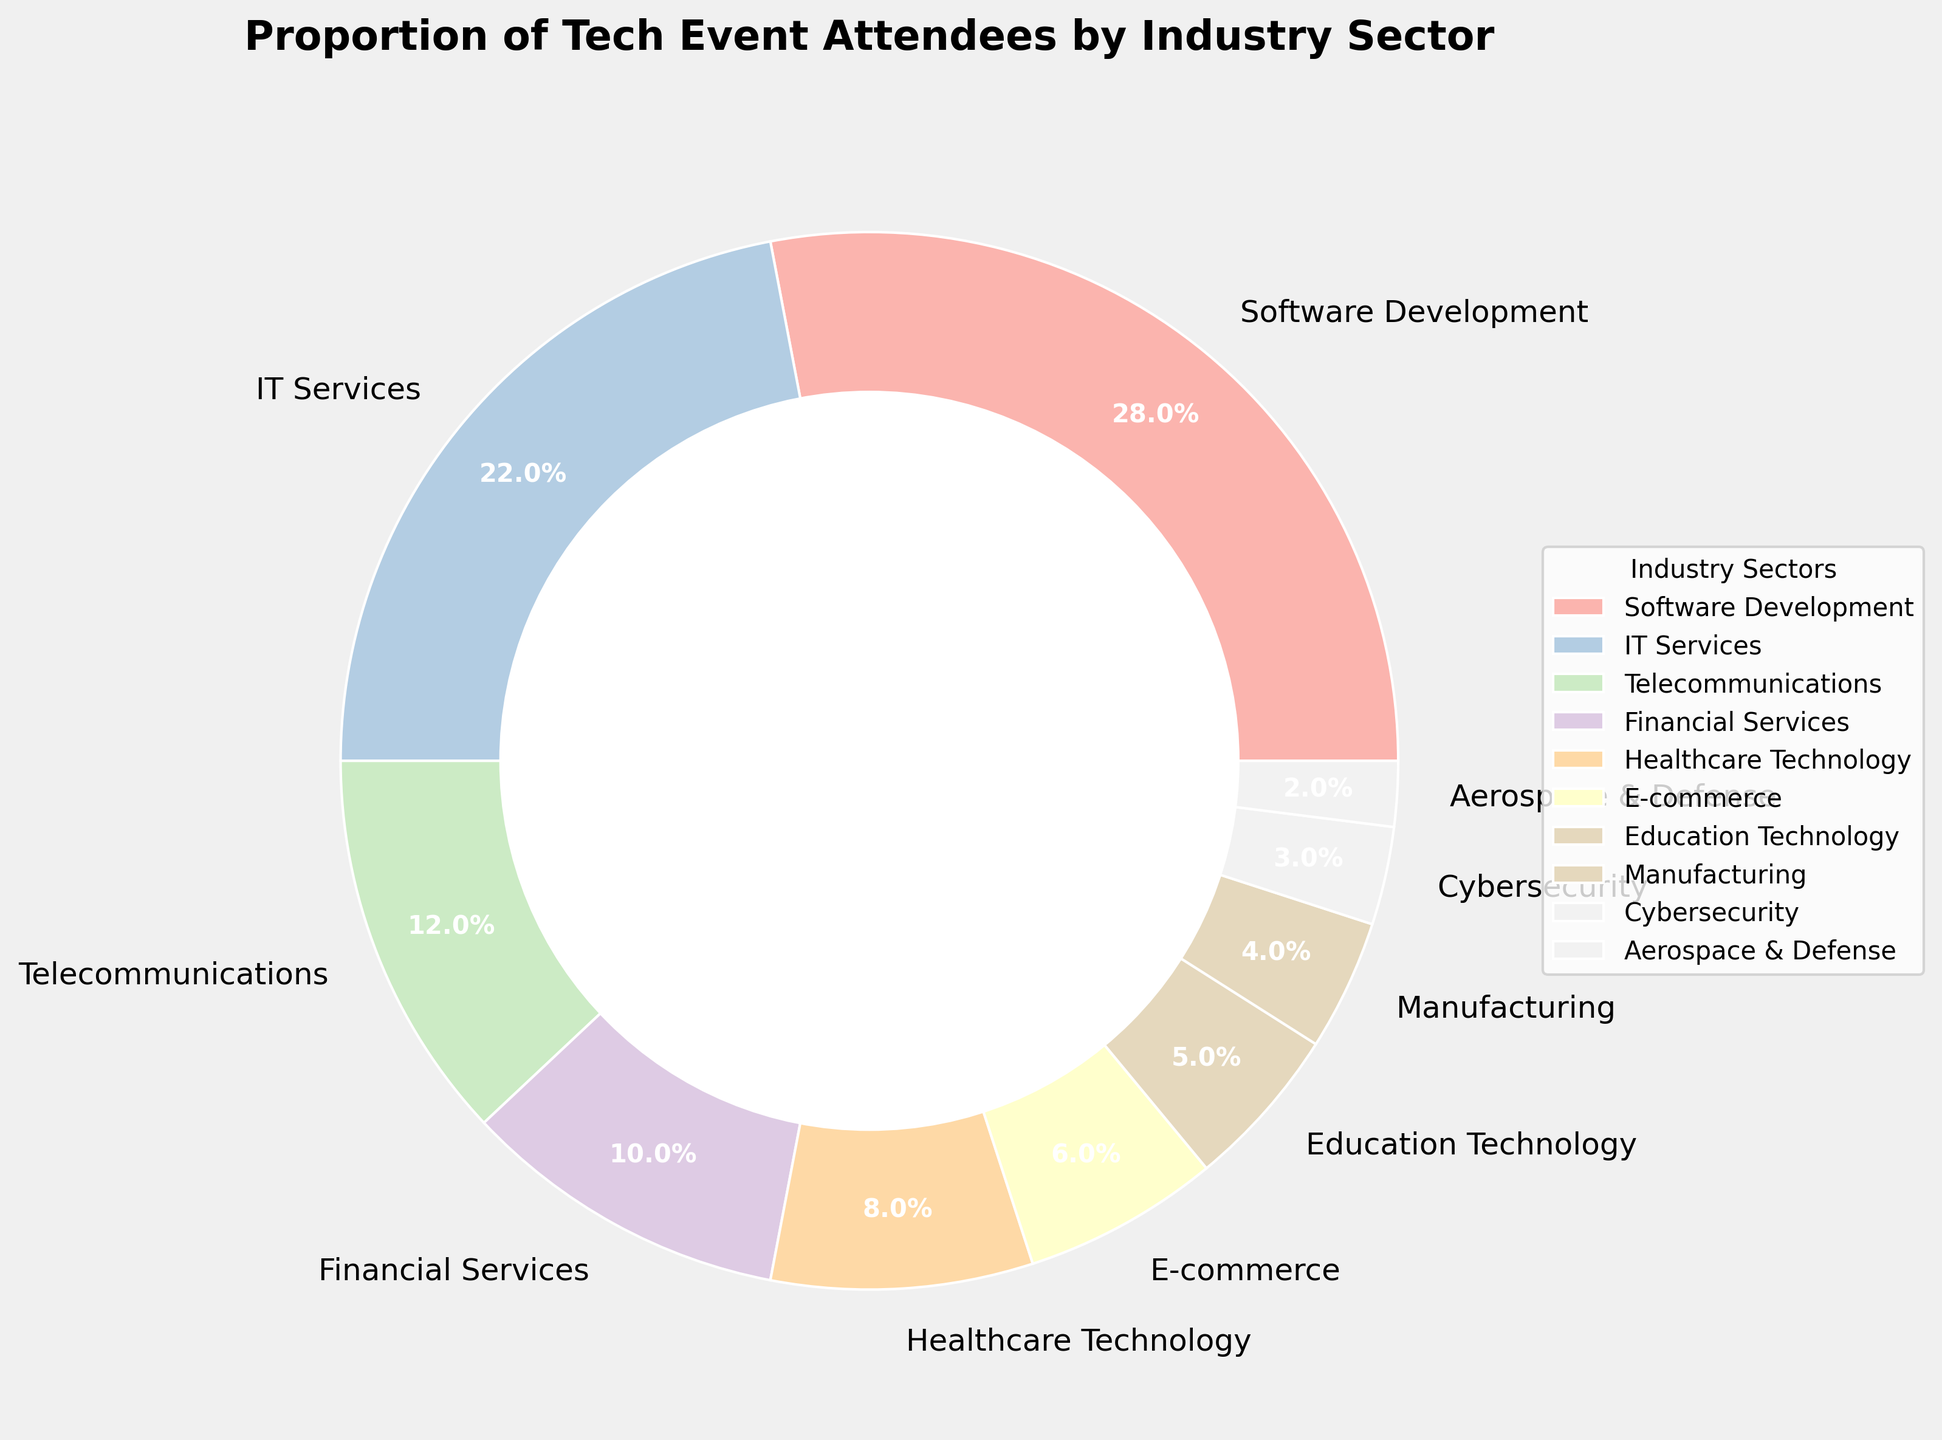What's the combined percentage of attendees from IT Services and Telecommunications? First, find the percentages for IT Services (22%) and Telecommunications (12%) in the pie chart. Then, add them together: 22% + 12% = 34%
Answer: 34% Which industry has the lowest proportion of attendees, and what is the percentage? Identify the smallest slice in the pie chart, representing Aerospace & Defense. The percentage for this sector is 2%
Answer: Aerospace & Defense, 2% Are there more attendees from Software Development or the combined total of attendees from Healthcare Technology and E-commerce? Find the percentages for Software Development (28%), Healthcare Technology (8%), and E-commerce (6%). Then, sum the percentages for Healthcare Technology and E-commerce: 8% + 6% = 14%. Since 28% (Software Development) is greater than 14% (combined), Software Development has more attendees
Answer: Software Development What's the proportion of attendees from sectors with less than 5% each? Identify the sectors with less than 5% each: Education Technology (5%), Manufacturing (4%), Cybersecurity (3%), and Aerospace & Defense (2%). Sum these percentages: 5% + 4% + 3% + 2% = 14%
Answer: 14% Which sector has a percentage that is a little more than one-fourth of the total attendees? One-fourth of the total is 25%. The sector nearest to this percentage is Software Development with 28%
Answer: Software Development What is the percentage difference between Financial Services and Healthcare Technology attendees? Find the percentages for Financial Services (10%) and Healthcare Technology (8%). Subtract the smaller percentage from the larger one: 10% - 8% = 2%
Answer: 2% Compare the proportions of attendees in IT Services and E-commerce; which one is larger and by how much? Find the percentages for IT Services (22%) and E-commerce (6%). Subtract the smaller percentage from the larger one: 22% - 6% = 16%. Since 22% is greater, IT Services has more attendees
Answer: IT Services, 16% What is the total percentage of attendees from Financial Services, Healthcare Technology, and E-commerce combined? Find the percentages for Financial Services (10%), Healthcare Technology (8%), and E-commerce (6%). Sum these percentages: 10% + 8% + 6% = 24%
Answer: 24% Which sector occupies a larger segment on the pie chart—Telecommunications or Healthcare Technology? Locate the percentages for Telecommunications (12%) and Healthcare Technology (8%) in the pie chart. 12% is greater than 8%, so Telecommunications occupies a larger segment
Answer: Telecommunications What is the average percentage of attendees from Cybersecurity and Manufacturing? Find the percentages for Cybersecurity (3%) and Manufacturing (4%). Add them together and divide by 2 to find the average: (3% + 4%) / 2 = 3.5%
Answer: 3.5% 